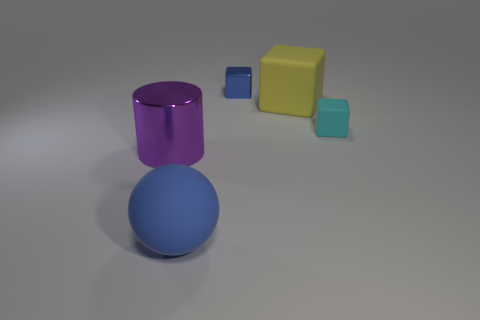Subtract all big yellow rubber blocks. How many blocks are left? 2 Subtract all blue blocks. Subtract all cyan balls. How many blocks are left? 2 Add 2 blocks. How many objects exist? 7 Subtract 0 green balls. How many objects are left? 5 Subtract all cylinders. How many objects are left? 4 Subtract 1 cylinders. How many cylinders are left? 0 Subtract all blue cubes. How many gray cylinders are left? 0 Subtract all big purple objects. Subtract all tiny blue cubes. How many objects are left? 3 Add 4 purple shiny things. How many purple shiny things are left? 5 Add 2 small blue blocks. How many small blue blocks exist? 3 